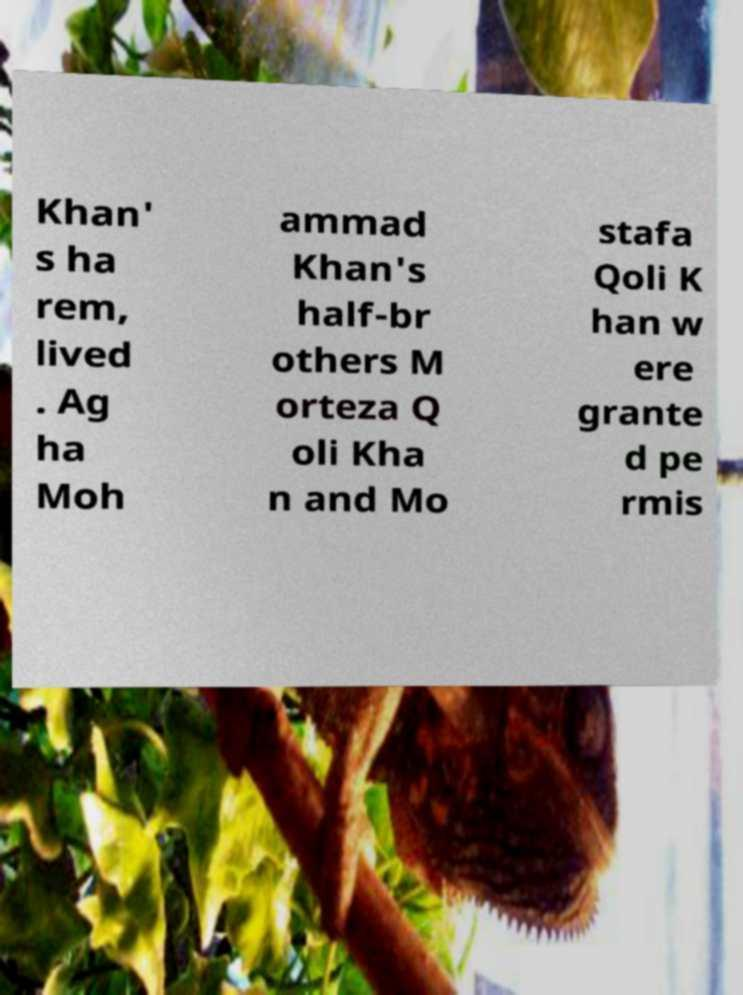Please read and relay the text visible in this image. What does it say? Khan' s ha rem, lived . Ag ha Moh ammad Khan's half-br others M orteza Q oli Kha n and Mo stafa Qoli K han w ere grante d pe rmis 